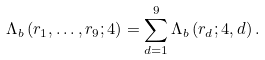Convert formula to latex. <formula><loc_0><loc_0><loc_500><loc_500>\Lambda _ { b } \left ( r _ { 1 } , \dots , r _ { 9 } ; 4 \right ) = \sum _ { d = 1 } ^ { 9 } \Lambda _ { b } \left ( r _ { d } ; 4 , d \right ) .</formula> 